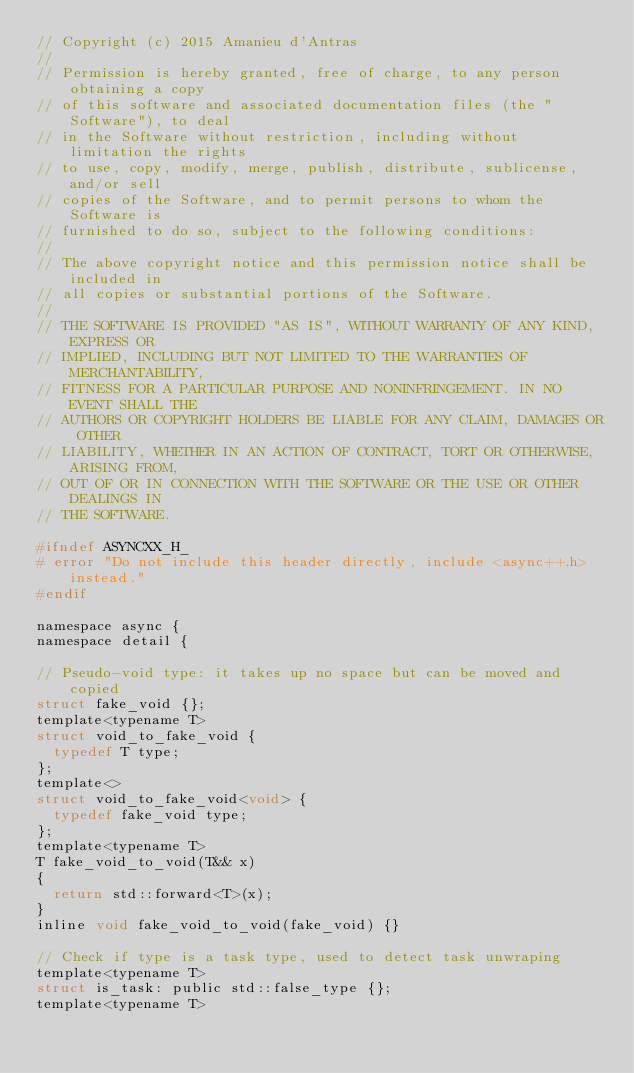Convert code to text. <code><loc_0><loc_0><loc_500><loc_500><_C_>// Copyright (c) 2015 Amanieu d'Antras
//
// Permission is hereby granted, free of charge, to any person obtaining a copy
// of this software and associated documentation files (the "Software"), to deal
// in the Software without restriction, including without limitation the rights
// to use, copy, modify, merge, publish, distribute, sublicense, and/or sell
// copies of the Software, and to permit persons to whom the Software is
// furnished to do so, subject to the following conditions:
//
// The above copyright notice and this permission notice shall be included in
// all copies or substantial portions of the Software.
//
// THE SOFTWARE IS PROVIDED "AS IS", WITHOUT WARRANTY OF ANY KIND, EXPRESS OR
// IMPLIED, INCLUDING BUT NOT LIMITED TO THE WARRANTIES OF MERCHANTABILITY,
// FITNESS FOR A PARTICULAR PURPOSE AND NONINFRINGEMENT. IN NO EVENT SHALL THE
// AUTHORS OR COPYRIGHT HOLDERS BE LIABLE FOR ANY CLAIM, DAMAGES OR OTHER
// LIABILITY, WHETHER IN AN ACTION OF CONTRACT, TORT OR OTHERWISE, ARISING FROM,
// OUT OF OR IN CONNECTION WITH THE SOFTWARE OR THE USE OR OTHER DEALINGS IN
// THE SOFTWARE.

#ifndef ASYNCXX_H_
# error "Do not include this header directly, include <async++.h> instead."
#endif

namespace async {
namespace detail {

// Pseudo-void type: it takes up no space but can be moved and copied
struct fake_void {};
template<typename T>
struct void_to_fake_void {
	typedef T type;
};
template<>
struct void_to_fake_void<void> {
	typedef fake_void type;
};
template<typename T>
T fake_void_to_void(T&& x)
{
	return std::forward<T>(x);
}
inline void fake_void_to_void(fake_void) {}

// Check if type is a task type, used to detect task unwraping
template<typename T>
struct is_task: public std::false_type {};
template<typename T></code> 